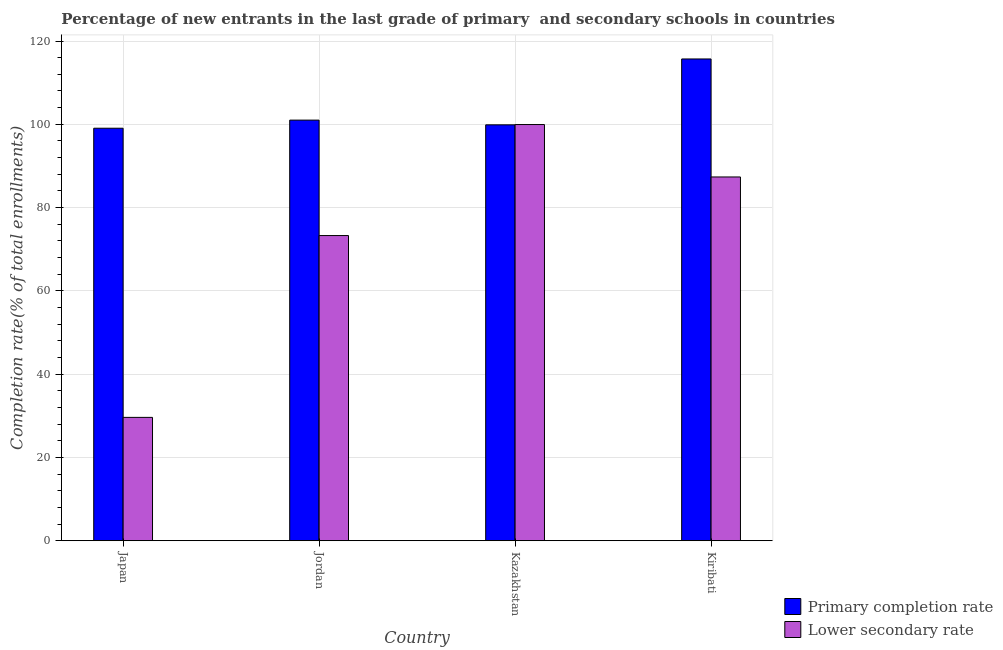How many bars are there on the 1st tick from the right?
Make the answer very short. 2. What is the label of the 2nd group of bars from the left?
Provide a short and direct response. Jordan. What is the completion rate in primary schools in Kiribati?
Your answer should be compact. 115.69. Across all countries, what is the maximum completion rate in secondary schools?
Offer a terse response. 99.94. Across all countries, what is the minimum completion rate in primary schools?
Give a very brief answer. 99.06. In which country was the completion rate in primary schools maximum?
Keep it short and to the point. Kiribati. What is the total completion rate in primary schools in the graph?
Provide a succinct answer. 415.62. What is the difference between the completion rate in primary schools in Jordan and that in Kazakhstan?
Your answer should be very brief. 1.13. What is the difference between the completion rate in secondary schools in Kiribati and the completion rate in primary schools in Jordan?
Your answer should be compact. -13.65. What is the average completion rate in secondary schools per country?
Give a very brief answer. 72.55. What is the difference between the completion rate in secondary schools and completion rate in primary schools in Jordan?
Provide a succinct answer. -27.72. In how many countries, is the completion rate in secondary schools greater than 68 %?
Ensure brevity in your answer.  3. What is the ratio of the completion rate in primary schools in Jordan to that in Kazakhstan?
Offer a terse response. 1.01. Is the difference between the completion rate in primary schools in Kazakhstan and Kiribati greater than the difference between the completion rate in secondary schools in Kazakhstan and Kiribati?
Provide a short and direct response. No. What is the difference between the highest and the second highest completion rate in primary schools?
Your response must be concise. 14.68. What is the difference between the highest and the lowest completion rate in secondary schools?
Your response must be concise. 70.32. In how many countries, is the completion rate in primary schools greater than the average completion rate in primary schools taken over all countries?
Your response must be concise. 1. What does the 1st bar from the left in Jordan represents?
Your answer should be compact. Primary completion rate. What does the 2nd bar from the right in Kiribati represents?
Offer a terse response. Primary completion rate. How many countries are there in the graph?
Provide a short and direct response. 4. What is the difference between two consecutive major ticks on the Y-axis?
Your answer should be compact. 20. Are the values on the major ticks of Y-axis written in scientific E-notation?
Keep it short and to the point. No. Where does the legend appear in the graph?
Make the answer very short. Bottom right. How are the legend labels stacked?
Offer a very short reply. Vertical. What is the title of the graph?
Your answer should be very brief. Percentage of new entrants in the last grade of primary  and secondary schools in countries. Does "2012 US$" appear as one of the legend labels in the graph?
Your response must be concise. No. What is the label or title of the X-axis?
Make the answer very short. Country. What is the label or title of the Y-axis?
Make the answer very short. Completion rate(% of total enrollments). What is the Completion rate(% of total enrollments) of Primary completion rate in Japan?
Your answer should be compact. 99.06. What is the Completion rate(% of total enrollments) in Lower secondary rate in Japan?
Offer a very short reply. 29.62. What is the Completion rate(% of total enrollments) of Primary completion rate in Jordan?
Your response must be concise. 101.01. What is the Completion rate(% of total enrollments) in Lower secondary rate in Jordan?
Your answer should be compact. 73.28. What is the Completion rate(% of total enrollments) of Primary completion rate in Kazakhstan?
Make the answer very short. 99.87. What is the Completion rate(% of total enrollments) of Lower secondary rate in Kazakhstan?
Ensure brevity in your answer.  99.94. What is the Completion rate(% of total enrollments) of Primary completion rate in Kiribati?
Your answer should be compact. 115.69. What is the Completion rate(% of total enrollments) of Lower secondary rate in Kiribati?
Your answer should be very brief. 87.36. Across all countries, what is the maximum Completion rate(% of total enrollments) of Primary completion rate?
Your answer should be very brief. 115.69. Across all countries, what is the maximum Completion rate(% of total enrollments) of Lower secondary rate?
Your answer should be compact. 99.94. Across all countries, what is the minimum Completion rate(% of total enrollments) in Primary completion rate?
Provide a short and direct response. 99.06. Across all countries, what is the minimum Completion rate(% of total enrollments) of Lower secondary rate?
Give a very brief answer. 29.62. What is the total Completion rate(% of total enrollments) in Primary completion rate in the graph?
Offer a very short reply. 415.62. What is the total Completion rate(% of total enrollments) in Lower secondary rate in the graph?
Your answer should be compact. 290.2. What is the difference between the Completion rate(% of total enrollments) of Primary completion rate in Japan and that in Jordan?
Give a very brief answer. -1.95. What is the difference between the Completion rate(% of total enrollments) in Lower secondary rate in Japan and that in Jordan?
Make the answer very short. -43.67. What is the difference between the Completion rate(% of total enrollments) in Primary completion rate in Japan and that in Kazakhstan?
Make the answer very short. -0.82. What is the difference between the Completion rate(% of total enrollments) of Lower secondary rate in Japan and that in Kazakhstan?
Your answer should be compact. -70.32. What is the difference between the Completion rate(% of total enrollments) of Primary completion rate in Japan and that in Kiribati?
Offer a terse response. -16.63. What is the difference between the Completion rate(% of total enrollments) in Lower secondary rate in Japan and that in Kiribati?
Your answer should be compact. -57.74. What is the difference between the Completion rate(% of total enrollments) in Primary completion rate in Jordan and that in Kazakhstan?
Your answer should be very brief. 1.13. What is the difference between the Completion rate(% of total enrollments) of Lower secondary rate in Jordan and that in Kazakhstan?
Provide a succinct answer. -26.66. What is the difference between the Completion rate(% of total enrollments) of Primary completion rate in Jordan and that in Kiribati?
Provide a succinct answer. -14.68. What is the difference between the Completion rate(% of total enrollments) of Lower secondary rate in Jordan and that in Kiribati?
Provide a succinct answer. -14.07. What is the difference between the Completion rate(% of total enrollments) in Primary completion rate in Kazakhstan and that in Kiribati?
Give a very brief answer. -15.82. What is the difference between the Completion rate(% of total enrollments) of Lower secondary rate in Kazakhstan and that in Kiribati?
Your response must be concise. 12.59. What is the difference between the Completion rate(% of total enrollments) of Primary completion rate in Japan and the Completion rate(% of total enrollments) of Lower secondary rate in Jordan?
Your answer should be compact. 25.77. What is the difference between the Completion rate(% of total enrollments) in Primary completion rate in Japan and the Completion rate(% of total enrollments) in Lower secondary rate in Kazakhstan?
Ensure brevity in your answer.  -0.89. What is the difference between the Completion rate(% of total enrollments) of Primary completion rate in Japan and the Completion rate(% of total enrollments) of Lower secondary rate in Kiribati?
Provide a short and direct response. 11.7. What is the difference between the Completion rate(% of total enrollments) in Primary completion rate in Jordan and the Completion rate(% of total enrollments) in Lower secondary rate in Kazakhstan?
Provide a short and direct response. 1.06. What is the difference between the Completion rate(% of total enrollments) of Primary completion rate in Jordan and the Completion rate(% of total enrollments) of Lower secondary rate in Kiribati?
Your response must be concise. 13.65. What is the difference between the Completion rate(% of total enrollments) of Primary completion rate in Kazakhstan and the Completion rate(% of total enrollments) of Lower secondary rate in Kiribati?
Give a very brief answer. 12.52. What is the average Completion rate(% of total enrollments) of Primary completion rate per country?
Your answer should be compact. 103.91. What is the average Completion rate(% of total enrollments) of Lower secondary rate per country?
Provide a succinct answer. 72.55. What is the difference between the Completion rate(% of total enrollments) of Primary completion rate and Completion rate(% of total enrollments) of Lower secondary rate in Japan?
Your response must be concise. 69.44. What is the difference between the Completion rate(% of total enrollments) in Primary completion rate and Completion rate(% of total enrollments) in Lower secondary rate in Jordan?
Ensure brevity in your answer.  27.72. What is the difference between the Completion rate(% of total enrollments) in Primary completion rate and Completion rate(% of total enrollments) in Lower secondary rate in Kazakhstan?
Provide a short and direct response. -0.07. What is the difference between the Completion rate(% of total enrollments) in Primary completion rate and Completion rate(% of total enrollments) in Lower secondary rate in Kiribati?
Keep it short and to the point. 28.33. What is the ratio of the Completion rate(% of total enrollments) in Primary completion rate in Japan to that in Jordan?
Make the answer very short. 0.98. What is the ratio of the Completion rate(% of total enrollments) in Lower secondary rate in Japan to that in Jordan?
Your response must be concise. 0.4. What is the ratio of the Completion rate(% of total enrollments) in Primary completion rate in Japan to that in Kazakhstan?
Provide a succinct answer. 0.99. What is the ratio of the Completion rate(% of total enrollments) in Lower secondary rate in Japan to that in Kazakhstan?
Keep it short and to the point. 0.3. What is the ratio of the Completion rate(% of total enrollments) of Primary completion rate in Japan to that in Kiribati?
Offer a very short reply. 0.86. What is the ratio of the Completion rate(% of total enrollments) in Lower secondary rate in Japan to that in Kiribati?
Give a very brief answer. 0.34. What is the ratio of the Completion rate(% of total enrollments) of Primary completion rate in Jordan to that in Kazakhstan?
Give a very brief answer. 1.01. What is the ratio of the Completion rate(% of total enrollments) of Lower secondary rate in Jordan to that in Kazakhstan?
Your response must be concise. 0.73. What is the ratio of the Completion rate(% of total enrollments) in Primary completion rate in Jordan to that in Kiribati?
Provide a succinct answer. 0.87. What is the ratio of the Completion rate(% of total enrollments) in Lower secondary rate in Jordan to that in Kiribati?
Give a very brief answer. 0.84. What is the ratio of the Completion rate(% of total enrollments) in Primary completion rate in Kazakhstan to that in Kiribati?
Offer a very short reply. 0.86. What is the ratio of the Completion rate(% of total enrollments) of Lower secondary rate in Kazakhstan to that in Kiribati?
Provide a short and direct response. 1.14. What is the difference between the highest and the second highest Completion rate(% of total enrollments) in Primary completion rate?
Make the answer very short. 14.68. What is the difference between the highest and the second highest Completion rate(% of total enrollments) in Lower secondary rate?
Offer a very short reply. 12.59. What is the difference between the highest and the lowest Completion rate(% of total enrollments) of Primary completion rate?
Provide a short and direct response. 16.63. What is the difference between the highest and the lowest Completion rate(% of total enrollments) of Lower secondary rate?
Give a very brief answer. 70.32. 